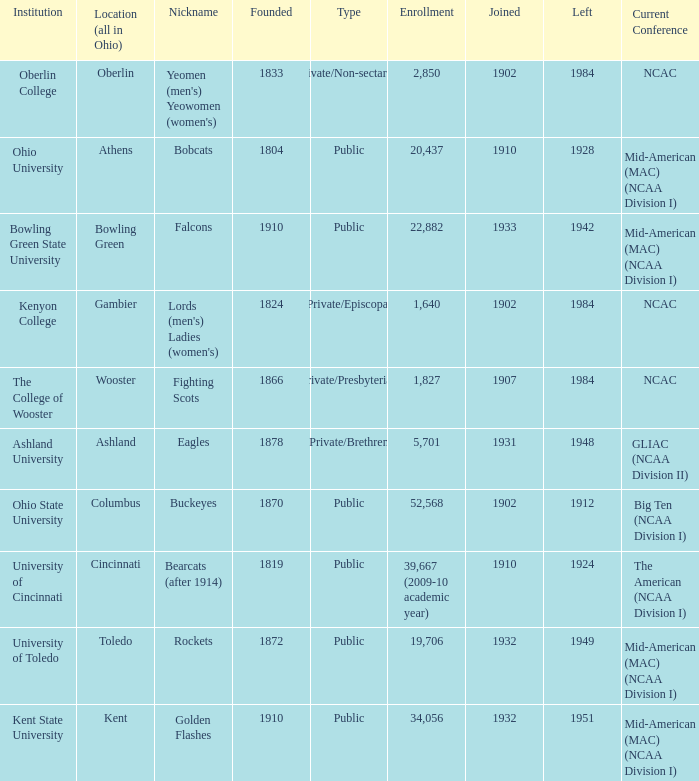What is the type of institution in Kent State University? Public. 